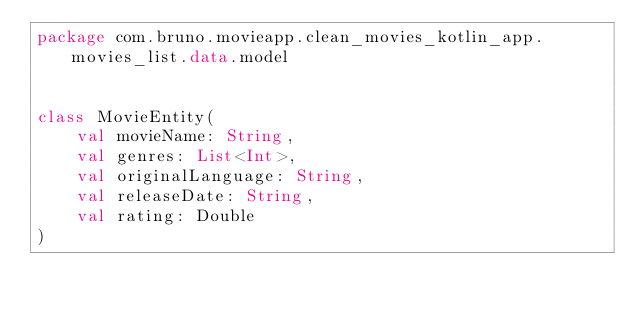Convert code to text. <code><loc_0><loc_0><loc_500><loc_500><_Kotlin_>package com.bruno.movieapp.clean_movies_kotlin_app.movies_list.data.model


class MovieEntity(
    val movieName: String,
    val genres: List<Int>,
    val originalLanguage: String,
    val releaseDate: String,
    val rating: Double
)</code> 